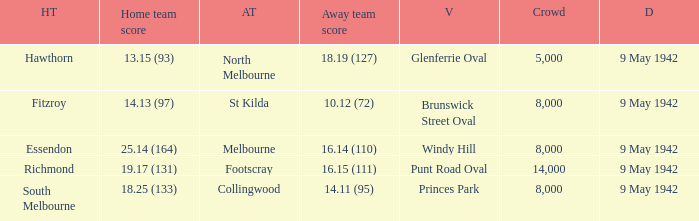How many people attended the game with the home team scoring 18.25 (133)? 1.0. 